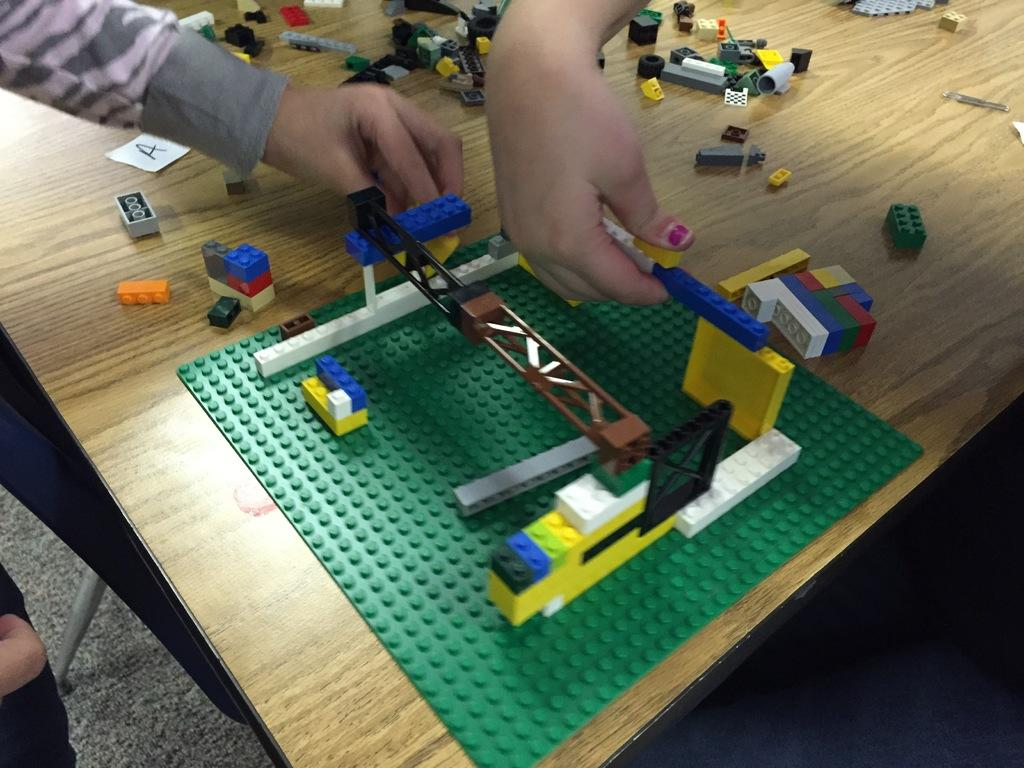How many people are in the foreground of the image? There are two persons in the foreground of the image. What are the two persons doing in the image? The two persons are building with building blocks. What can be seen on the hands of the two persons? The hands of the two persons are visible in the image. What type of surface is present in the image? There is a wooden surface in the image. What else can be seen on the table besides the wooden surface? There are pieces of building blocks on the table. Can you see any schools or oceans in the image? No, there are no schools or oceans present in the image. What type of army is depicted in the image? There is no army depicted in the image; it features two persons building with building blocks. 